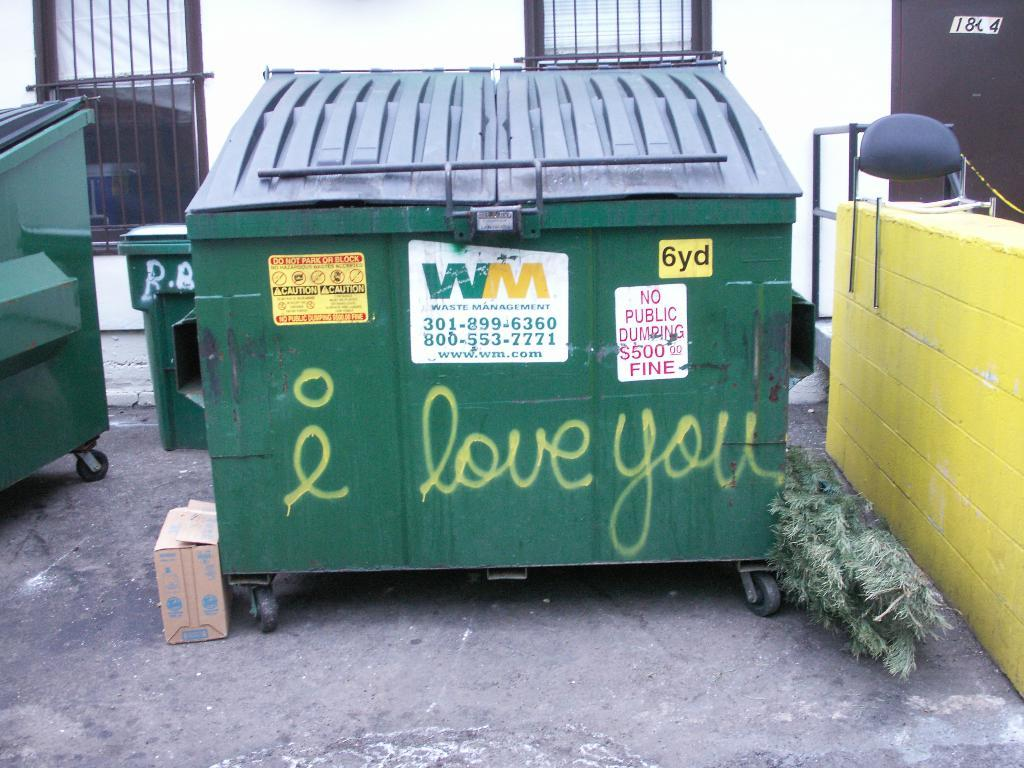Provide a one-sentence caption for the provided image. Love you is written in yellow on a green dumpster. 